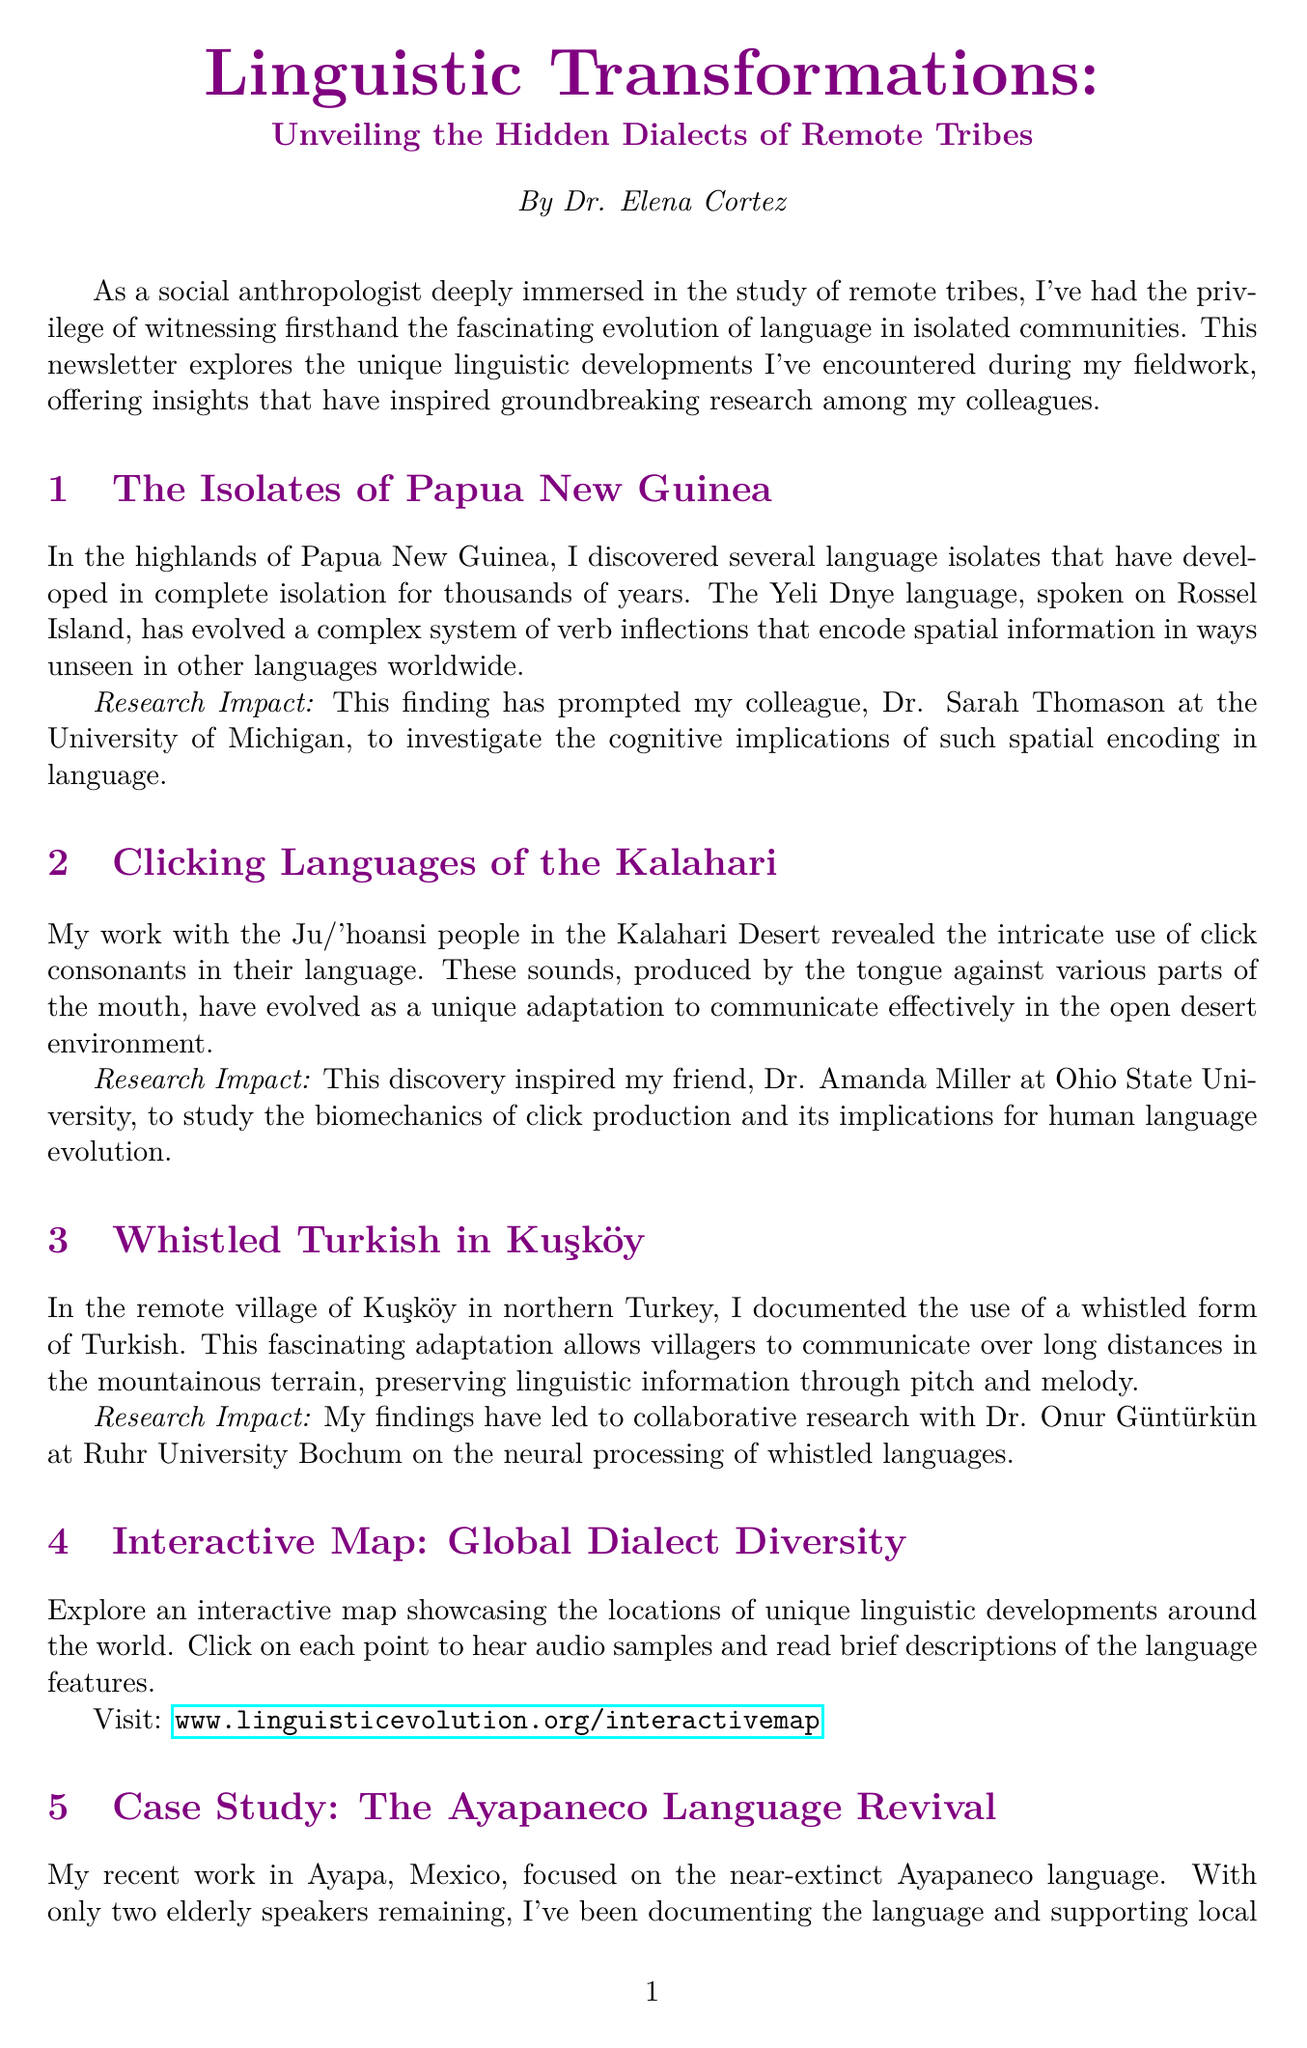What is the title of the newsletter? The title is prominently displayed at the beginning of the newsletter.
Answer: Linguistic Transformations: Unveiling the Hidden Dialects of Remote Tribes Who is the author of the newsletter? The author is introduced in the "About the Author" section.
Answer: Dr. Elena Cortez What language is spoken on Rossel Island? The specific language mentioned in the section about Papua New Guinea is referred to.
Answer: Yeli Dnye How many elderly speakers remain of the Ayapaneco language? The number of remaining speakers is highlighted in the case study about Ayapaneco.
Answer: Two What adaptation allows Kuşköy villagers to communicate over long distances? This is discussed in the section on Whistled Turkish and describes a unique method of communication.
Answer: Whistled form of Turkish Which university is Dr. Sarah Thomason affiliated with? The affiliation of this researcher is stated in the context of her work related to spatial encoding in language.
Answer: University of Michigan What is included in the interactive map? The description of the interactive map outlines its features as part of the newsletter.
Answer: Audio samples and brief descriptions What is the impact of the case study on Ayapaneco language? This highlights a key outcome from the case study presented in the newsletter.
Answer: Development of new methodologies for rapid language documentation and revival strategies What type of languages does Dr. Gabriela Pérez focus on? This is inferred from the impact of the Ayapaneco language revival project mentioned in the document.
Answer: Endangered languages 